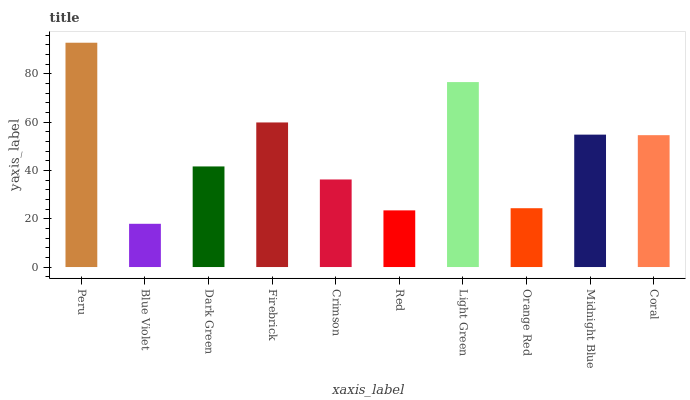Is Blue Violet the minimum?
Answer yes or no. Yes. Is Peru the maximum?
Answer yes or no. Yes. Is Dark Green the minimum?
Answer yes or no. No. Is Dark Green the maximum?
Answer yes or no. No. Is Dark Green greater than Blue Violet?
Answer yes or no. Yes. Is Blue Violet less than Dark Green?
Answer yes or no. Yes. Is Blue Violet greater than Dark Green?
Answer yes or no. No. Is Dark Green less than Blue Violet?
Answer yes or no. No. Is Coral the high median?
Answer yes or no. Yes. Is Dark Green the low median?
Answer yes or no. Yes. Is Red the high median?
Answer yes or no. No. Is Midnight Blue the low median?
Answer yes or no. No. 